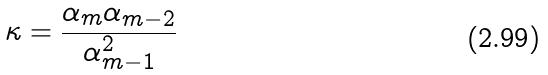<formula> <loc_0><loc_0><loc_500><loc_500>\kappa = \frac { \alpha _ { m } \alpha _ { m - 2 } } { \alpha _ { m - 1 } ^ { 2 } }</formula> 